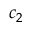<formula> <loc_0><loc_0><loc_500><loc_500>c _ { 2 }</formula> 